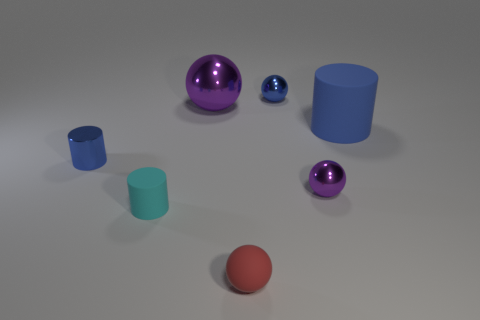Add 1 tiny blue shiny objects. How many objects exist? 8 Subtract all cyan cylinders. How many cylinders are left? 2 Subtract all cylinders. How many objects are left? 4 Subtract 1 balls. How many balls are left? 3 Subtract all blue balls. Subtract all cyan cubes. How many balls are left? 3 Subtract all blue balls. How many blue cylinders are left? 2 Subtract all rubber cylinders. Subtract all big blue objects. How many objects are left? 4 Add 7 small blue metal things. How many small blue metal things are left? 9 Add 5 tiny blue shiny cylinders. How many tiny blue shiny cylinders exist? 6 Subtract all cyan cylinders. How many cylinders are left? 2 